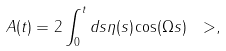Convert formula to latex. <formula><loc_0><loc_0><loc_500><loc_500>A ( t ) = 2 \int ^ { t } _ { 0 } d s \eta ( s ) \cos ( \Omega s ) \ > ,</formula> 